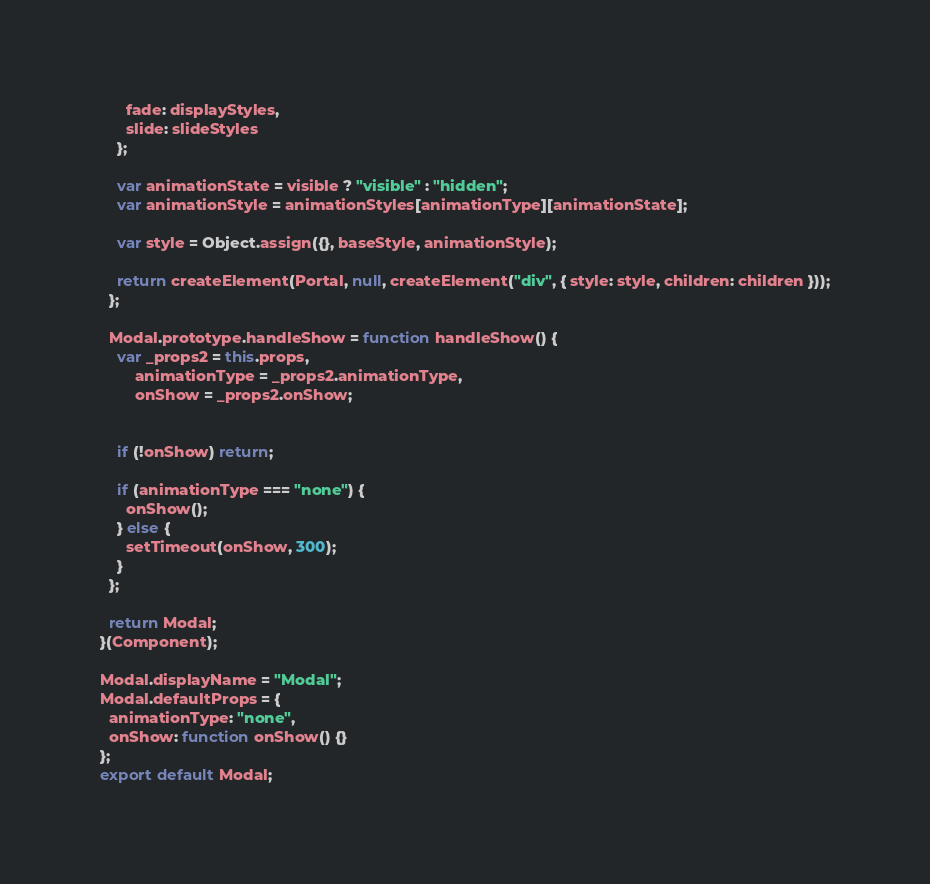<code> <loc_0><loc_0><loc_500><loc_500><_JavaScript_>      fade: displayStyles,
      slide: slideStyles
    };

    var animationState = visible ? "visible" : "hidden";
    var animationStyle = animationStyles[animationType][animationState];

    var style = Object.assign({}, baseStyle, animationStyle);

    return createElement(Portal, null, createElement("div", { style: style, children: children }));
  };

  Modal.prototype.handleShow = function handleShow() {
    var _props2 = this.props,
        animationType = _props2.animationType,
        onShow = _props2.onShow;


    if (!onShow) return;

    if (animationType === "none") {
      onShow();
    } else {
      setTimeout(onShow, 300);
    }
  };

  return Modal;
}(Component);

Modal.displayName = "Modal";
Modal.defaultProps = {
  animationType: "none",
  onShow: function onShow() {}
};
export default Modal;</code> 